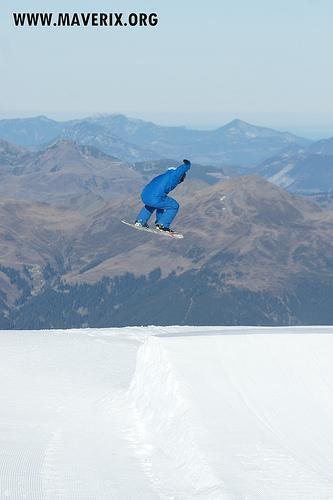How many people are shown?
Give a very brief answer. 1. 